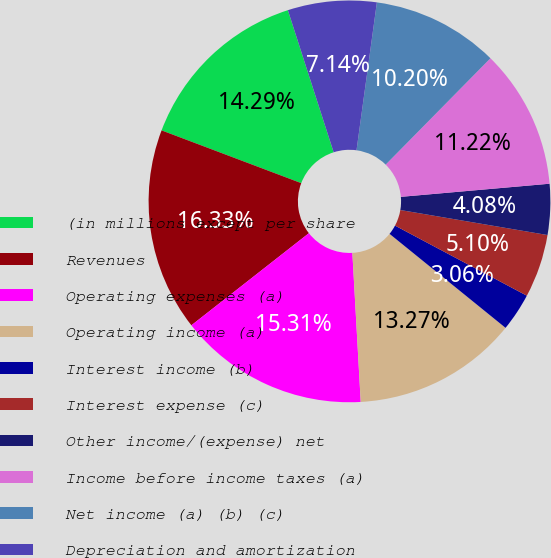<chart> <loc_0><loc_0><loc_500><loc_500><pie_chart><fcel>(in millions except per share<fcel>Revenues<fcel>Operating expenses (a)<fcel>Operating income (a)<fcel>Interest income (b)<fcel>Interest expense (c)<fcel>Other income/(expense) net<fcel>Income before income taxes (a)<fcel>Net income (a) (b) (c)<fcel>Depreciation and amortization<nl><fcel>14.29%<fcel>16.33%<fcel>15.31%<fcel>13.27%<fcel>3.06%<fcel>5.1%<fcel>4.08%<fcel>11.22%<fcel>10.2%<fcel>7.14%<nl></chart> 